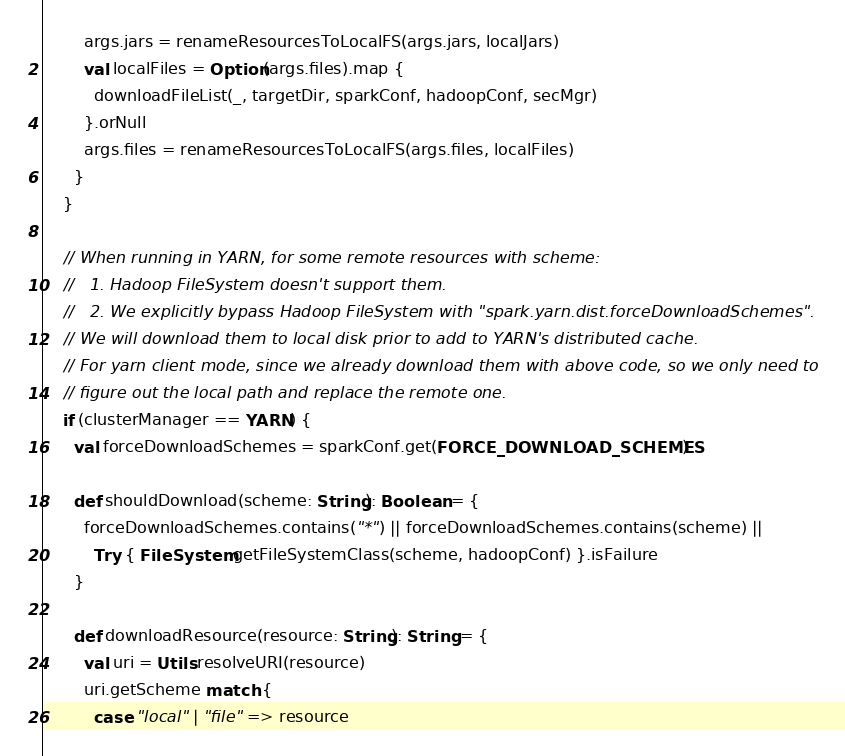<code> <loc_0><loc_0><loc_500><loc_500><_Scala_>        args.jars = renameResourcesToLocalFS(args.jars, localJars)
        val localFiles = Option(args.files).map {
          downloadFileList(_, targetDir, sparkConf, hadoopConf, secMgr)
        }.orNull
        args.files = renameResourcesToLocalFS(args.files, localFiles)
      }
    }

    // When running in YARN, for some remote resources with scheme:
    //   1. Hadoop FileSystem doesn't support them.
    //   2. We explicitly bypass Hadoop FileSystem with "spark.yarn.dist.forceDownloadSchemes".
    // We will download them to local disk prior to add to YARN's distributed cache.
    // For yarn client mode, since we already download them with above code, so we only need to
    // figure out the local path and replace the remote one.
    if (clusterManager == YARN) {
      val forceDownloadSchemes = sparkConf.get(FORCE_DOWNLOAD_SCHEMES)

      def shouldDownload(scheme: String): Boolean = {
        forceDownloadSchemes.contains("*") || forceDownloadSchemes.contains(scheme) ||
          Try { FileSystem.getFileSystemClass(scheme, hadoopConf) }.isFailure
      }

      def downloadResource(resource: String): String = {
        val uri = Utils.resolveURI(resource)
        uri.getScheme match {
          case "local" | "file" => resource</code> 